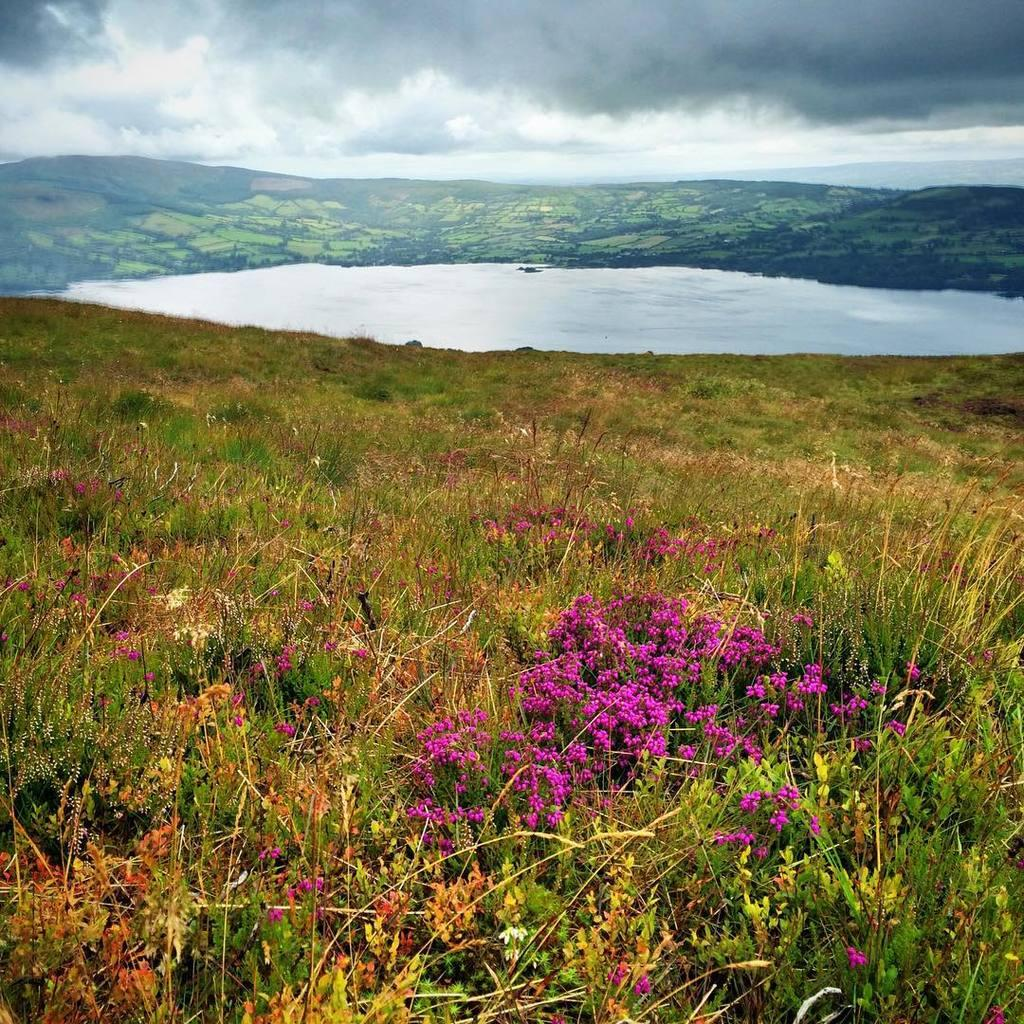What type of vegetation can be seen in the image? There are plants in the image. What is on the ground in the image? There is grass on the ground. What can be seen in the background of the image? There is water and a hill visible in the background. What is visible in the sky at the top of the image? There are clouds in the sky at the top of the image. How does the scarecrow show respect to the fire in the image? There is no scarecrow or fire present in the image. 